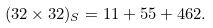Convert formula to latex. <formula><loc_0><loc_0><loc_500><loc_500>( 3 2 \times 3 2 ) _ { S } = 1 1 + 5 5 + 4 6 2 .</formula> 